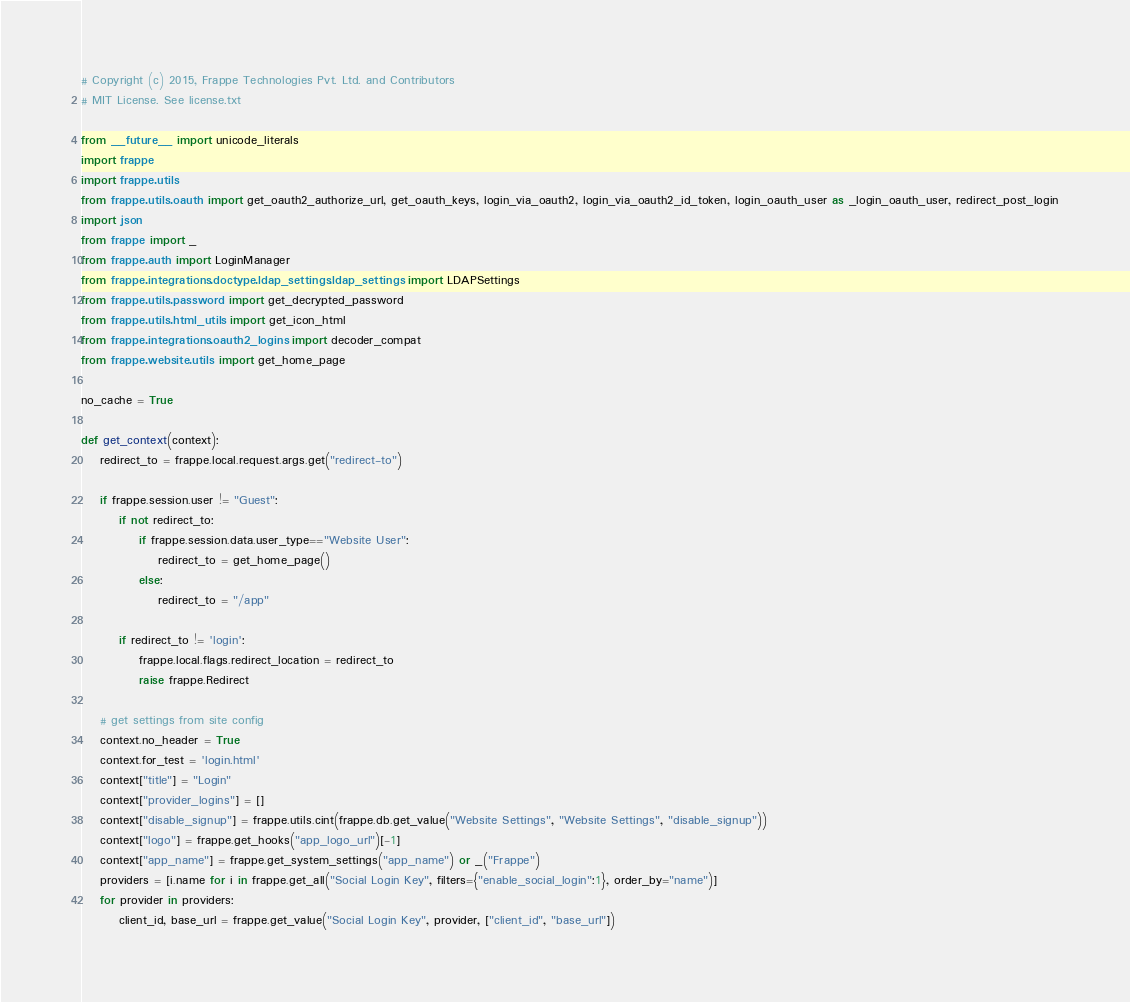Convert code to text. <code><loc_0><loc_0><loc_500><loc_500><_Python_># Copyright (c) 2015, Frappe Technologies Pvt. Ltd. and Contributors
# MIT License. See license.txt

from __future__ import unicode_literals
import frappe
import frappe.utils
from frappe.utils.oauth import get_oauth2_authorize_url, get_oauth_keys, login_via_oauth2, login_via_oauth2_id_token, login_oauth_user as _login_oauth_user, redirect_post_login
import json
from frappe import _
from frappe.auth import LoginManager
from frappe.integrations.doctype.ldap_settings.ldap_settings import LDAPSettings
from frappe.utils.password import get_decrypted_password
from frappe.utils.html_utils import get_icon_html
from frappe.integrations.oauth2_logins import decoder_compat
from frappe.website.utils import get_home_page

no_cache = True

def get_context(context):
	redirect_to = frappe.local.request.args.get("redirect-to")

	if frappe.session.user != "Guest":
		if not redirect_to:
			if frappe.session.data.user_type=="Website User":
				redirect_to = get_home_page()
			else:
				redirect_to = "/app"

		if redirect_to != 'login':
			frappe.local.flags.redirect_location = redirect_to
			raise frappe.Redirect

	# get settings from site config
	context.no_header = True
	context.for_test = 'login.html'
	context["title"] = "Login"
	context["provider_logins"] = []
	context["disable_signup"] = frappe.utils.cint(frappe.db.get_value("Website Settings", "Website Settings", "disable_signup"))
	context["logo"] = frappe.get_hooks("app_logo_url")[-1]
	context["app_name"] = frappe.get_system_settings("app_name") or _("Frappe")
	providers = [i.name for i in frappe.get_all("Social Login Key", filters={"enable_social_login":1}, order_by="name")]
	for provider in providers:
		client_id, base_url = frappe.get_value("Social Login Key", provider, ["client_id", "base_url"])</code> 